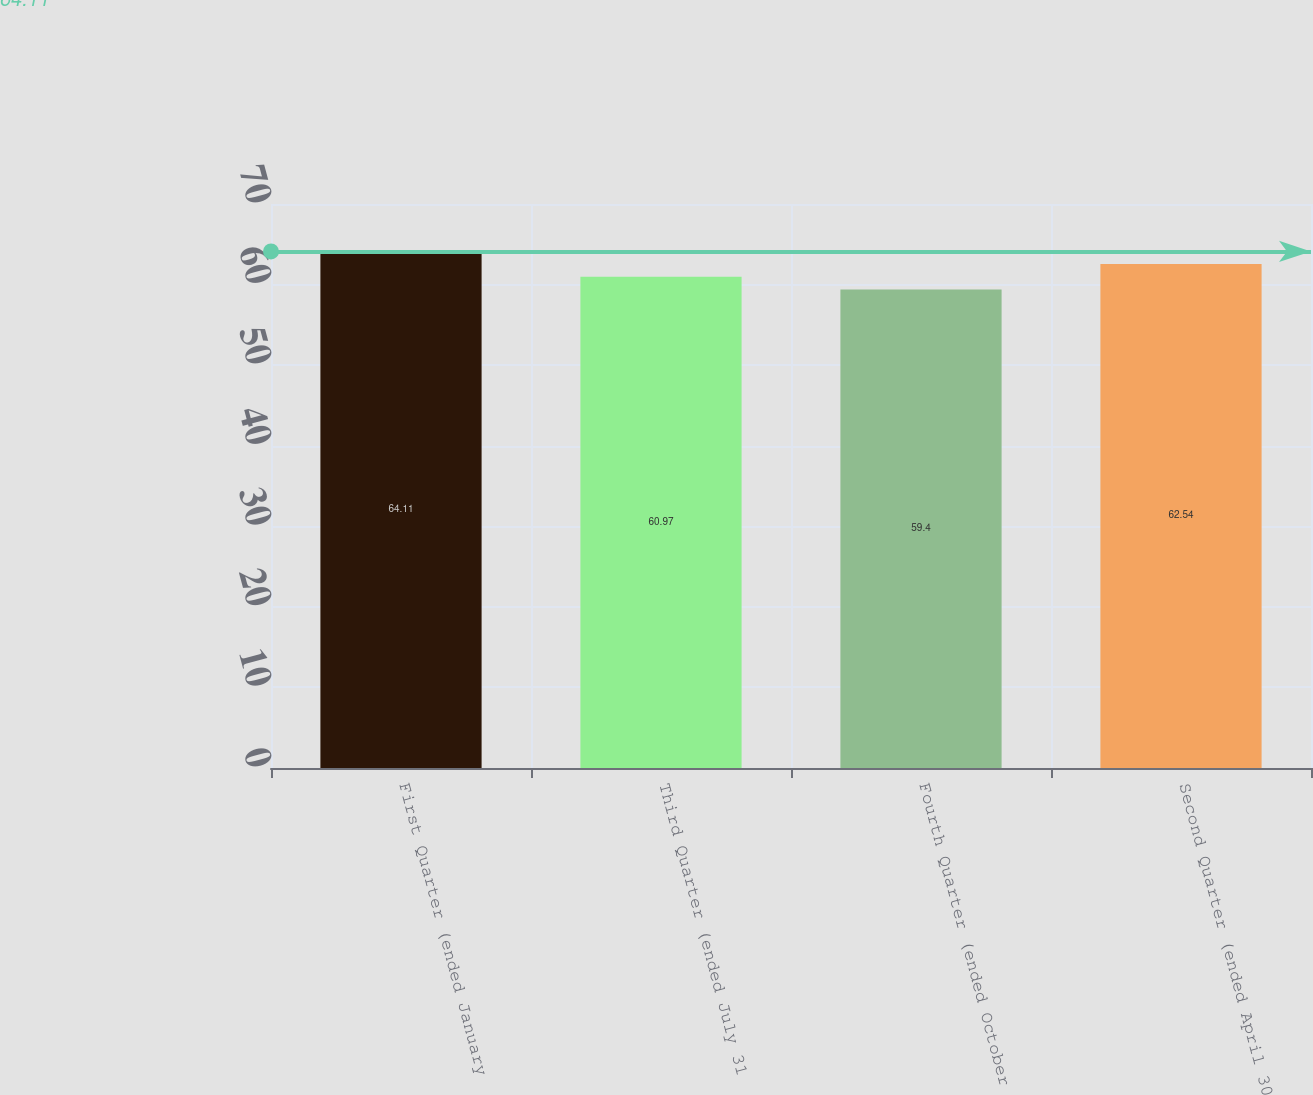Convert chart to OTSL. <chart><loc_0><loc_0><loc_500><loc_500><bar_chart><fcel>First Quarter (ended January<fcel>Third Quarter (ended July 31<fcel>Fourth Quarter (ended October<fcel>Second Quarter (ended April 30<nl><fcel>64.11<fcel>60.97<fcel>59.4<fcel>62.54<nl></chart> 